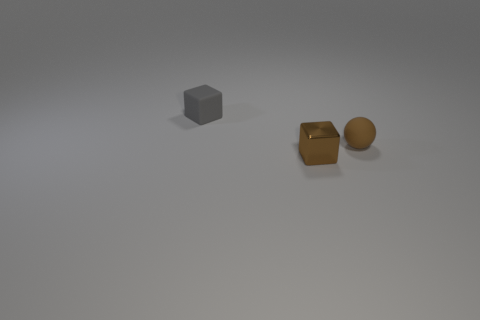Add 2 small brown things. How many objects exist? 5 Subtract all blocks. How many objects are left? 1 Add 3 small objects. How many small objects exist? 6 Subtract 1 brown spheres. How many objects are left? 2 Subtract all small brown cubes. Subtract all brown shiny objects. How many objects are left? 1 Add 2 gray things. How many gray things are left? 3 